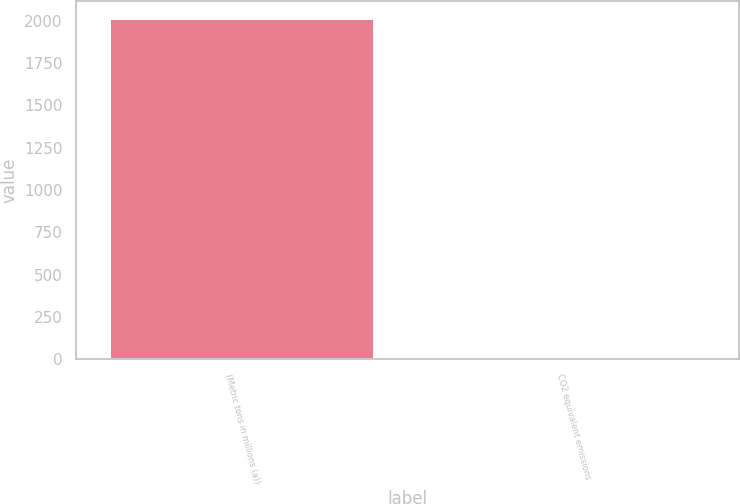Convert chart to OTSL. <chart><loc_0><loc_0><loc_500><loc_500><bar_chart><fcel>(Metric tons in millions (a))<fcel>CO2 equivalent emissions<nl><fcel>2014<fcel>3.2<nl></chart> 